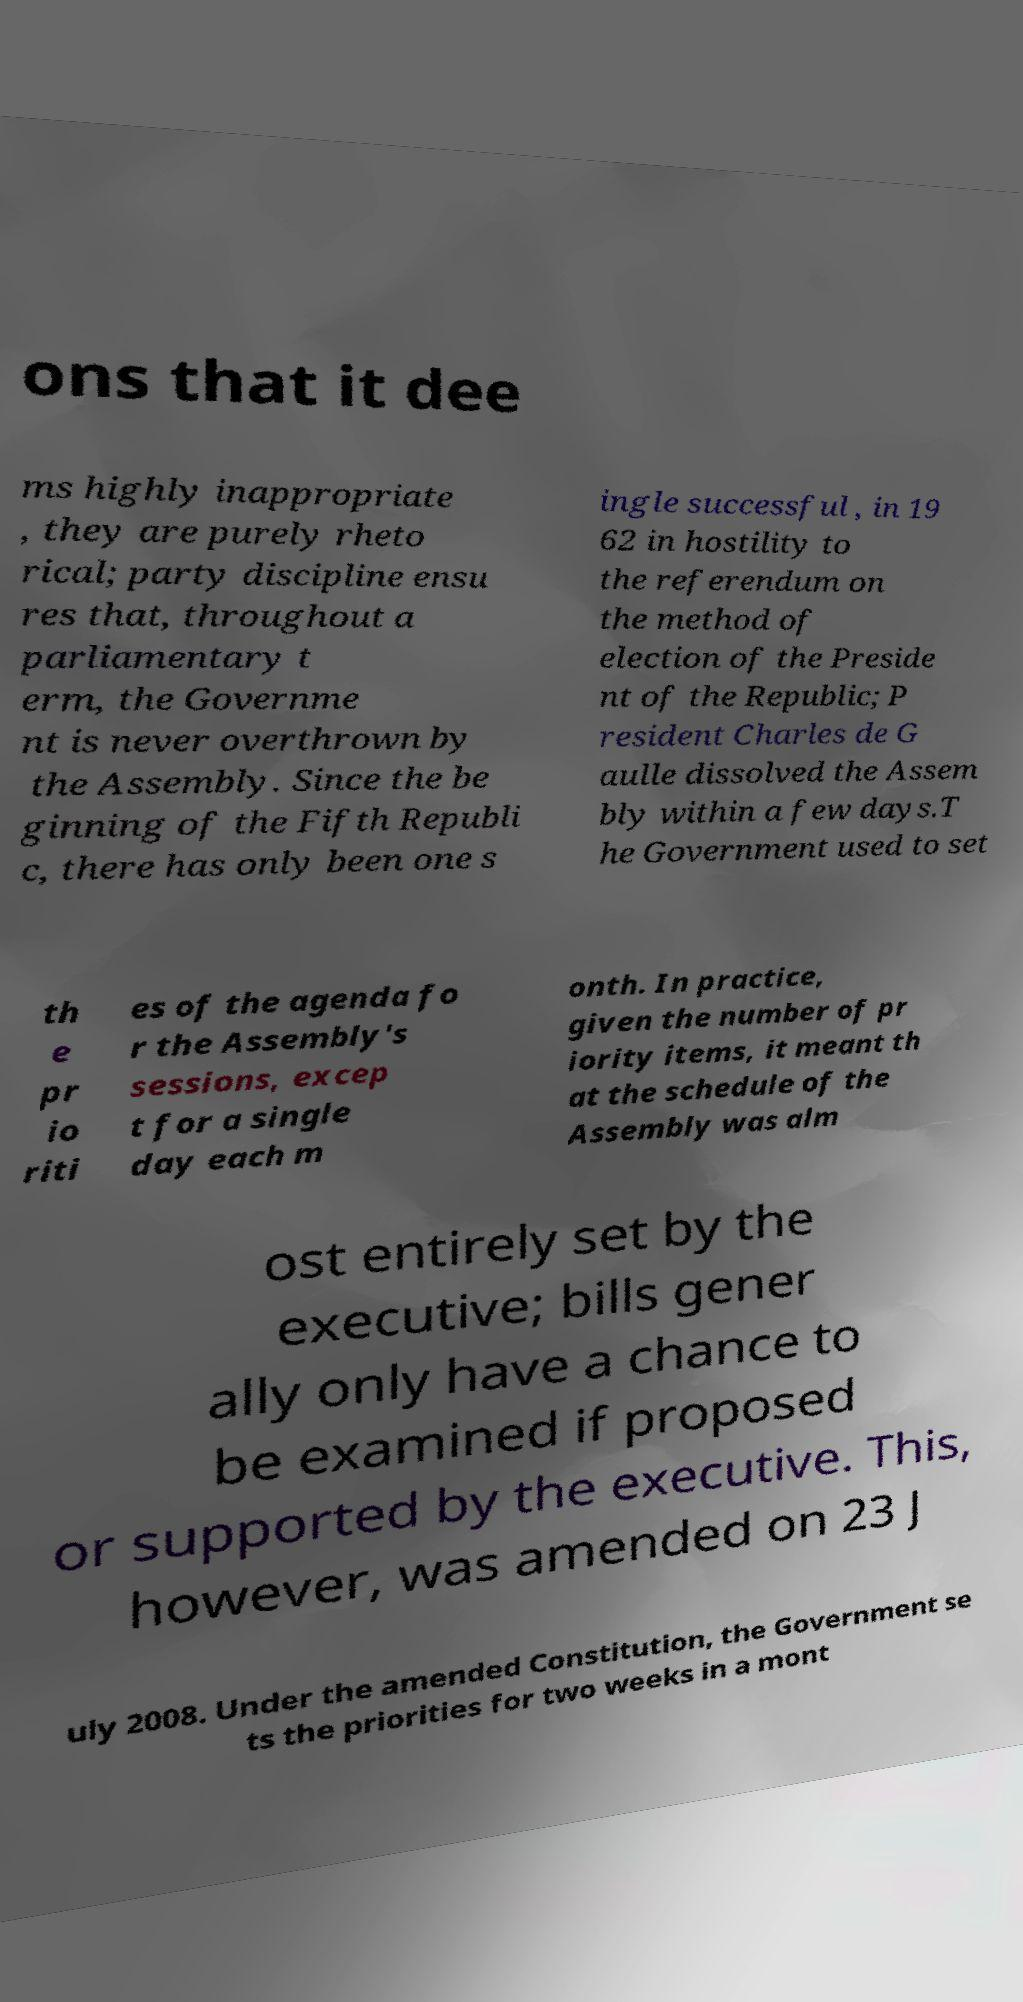Could you extract and type out the text from this image? ons that it dee ms highly inappropriate , they are purely rheto rical; party discipline ensu res that, throughout a parliamentary t erm, the Governme nt is never overthrown by the Assembly. Since the be ginning of the Fifth Republi c, there has only been one s ingle successful , in 19 62 in hostility to the referendum on the method of election of the Preside nt of the Republic; P resident Charles de G aulle dissolved the Assem bly within a few days.T he Government used to set th e pr io riti es of the agenda fo r the Assembly's sessions, excep t for a single day each m onth. In practice, given the number of pr iority items, it meant th at the schedule of the Assembly was alm ost entirely set by the executive; bills gener ally only have a chance to be examined if proposed or supported by the executive. This, however, was amended on 23 J uly 2008. Under the amended Constitution, the Government se ts the priorities for two weeks in a mont 